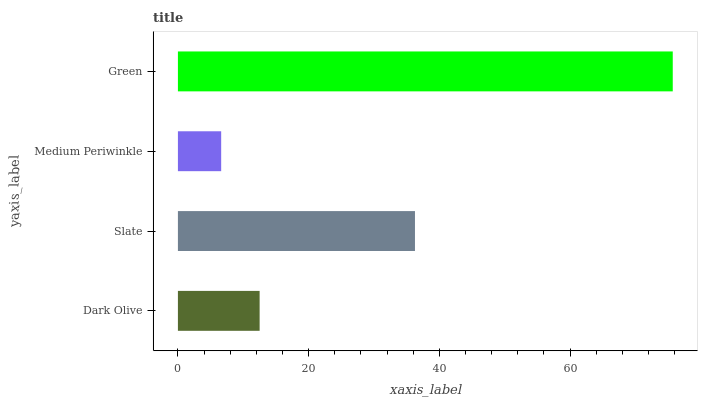Is Medium Periwinkle the minimum?
Answer yes or no. Yes. Is Green the maximum?
Answer yes or no. Yes. Is Slate the minimum?
Answer yes or no. No. Is Slate the maximum?
Answer yes or no. No. Is Slate greater than Dark Olive?
Answer yes or no. Yes. Is Dark Olive less than Slate?
Answer yes or no. Yes. Is Dark Olive greater than Slate?
Answer yes or no. No. Is Slate less than Dark Olive?
Answer yes or no. No. Is Slate the high median?
Answer yes or no. Yes. Is Dark Olive the low median?
Answer yes or no. Yes. Is Dark Olive the high median?
Answer yes or no. No. Is Medium Periwinkle the low median?
Answer yes or no. No. 